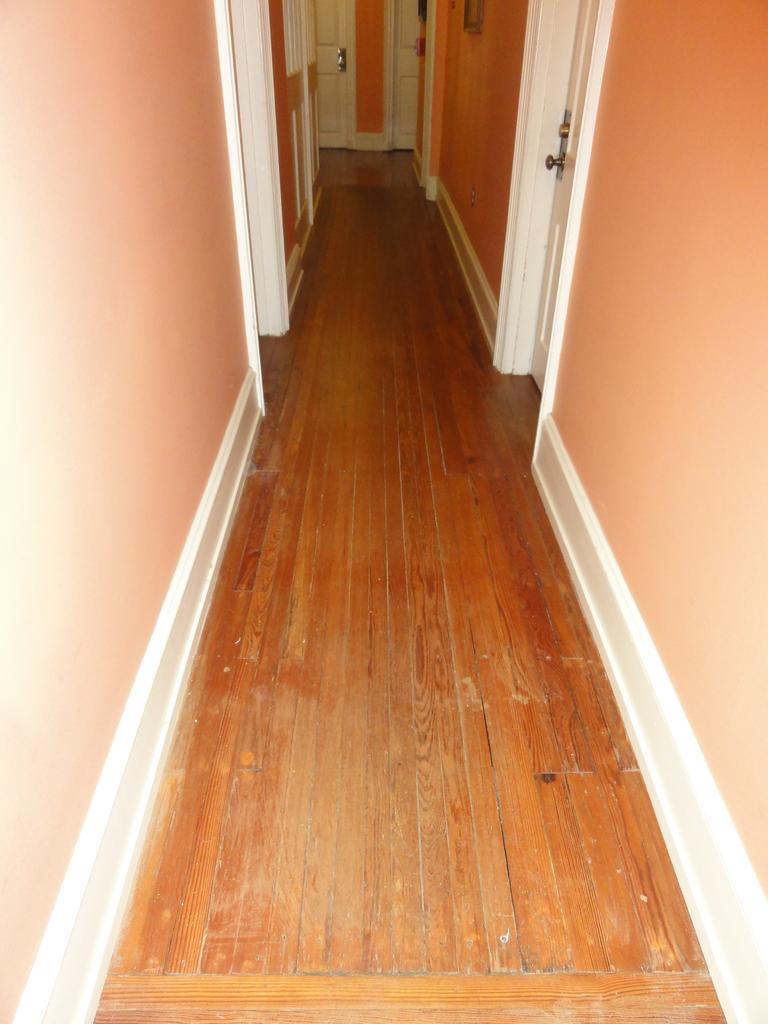Please provide a concise description of this image. In this image, I can see a wooden floor and there are doors. At the top of the image, I can see an object attached to the wall. 